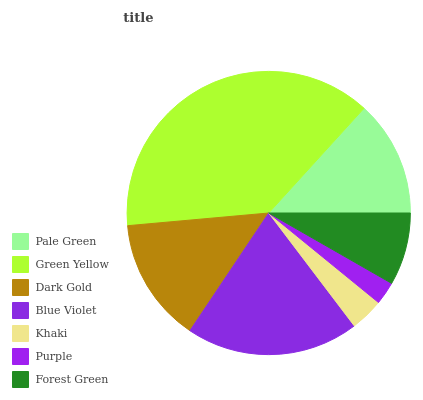Is Purple the minimum?
Answer yes or no. Yes. Is Green Yellow the maximum?
Answer yes or no. Yes. Is Dark Gold the minimum?
Answer yes or no. No. Is Dark Gold the maximum?
Answer yes or no. No. Is Green Yellow greater than Dark Gold?
Answer yes or no. Yes. Is Dark Gold less than Green Yellow?
Answer yes or no. Yes. Is Dark Gold greater than Green Yellow?
Answer yes or no. No. Is Green Yellow less than Dark Gold?
Answer yes or no. No. Is Pale Green the high median?
Answer yes or no. Yes. Is Pale Green the low median?
Answer yes or no. Yes. Is Purple the high median?
Answer yes or no. No. Is Blue Violet the low median?
Answer yes or no. No. 